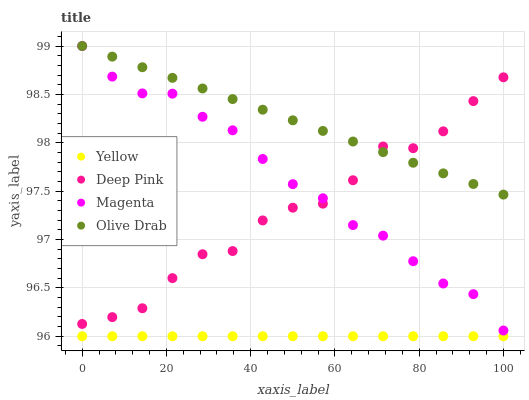Does Yellow have the minimum area under the curve?
Answer yes or no. Yes. Does Olive Drab have the maximum area under the curve?
Answer yes or no. Yes. Does Deep Pink have the minimum area under the curve?
Answer yes or no. No. Does Deep Pink have the maximum area under the curve?
Answer yes or no. No. Is Yellow the smoothest?
Answer yes or no. Yes. Is Deep Pink the roughest?
Answer yes or no. Yes. Is Olive Drab the smoothest?
Answer yes or no. No. Is Olive Drab the roughest?
Answer yes or no. No. Does Yellow have the lowest value?
Answer yes or no. Yes. Does Deep Pink have the lowest value?
Answer yes or no. No. Does Olive Drab have the highest value?
Answer yes or no. Yes. Does Deep Pink have the highest value?
Answer yes or no. No. Is Yellow less than Olive Drab?
Answer yes or no. Yes. Is Magenta greater than Yellow?
Answer yes or no. Yes. Does Olive Drab intersect Magenta?
Answer yes or no. Yes. Is Olive Drab less than Magenta?
Answer yes or no. No. Is Olive Drab greater than Magenta?
Answer yes or no. No. Does Yellow intersect Olive Drab?
Answer yes or no. No. 